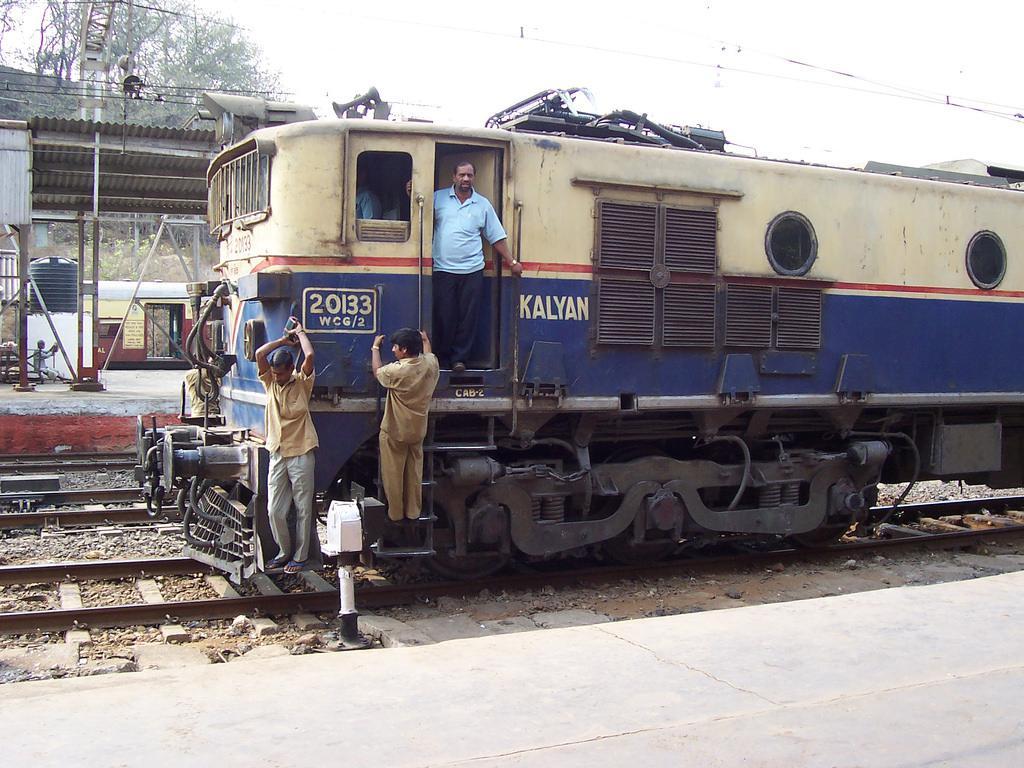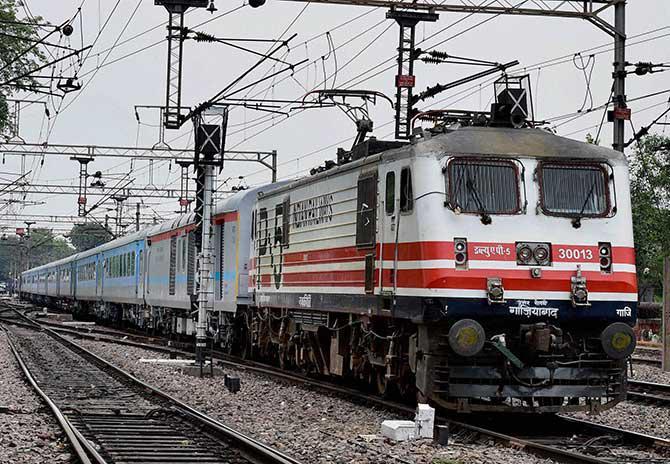The first image is the image on the left, the second image is the image on the right. Assess this claim about the two images: "There are two trains in one of the images.". Correct or not? Answer yes or no. No. 